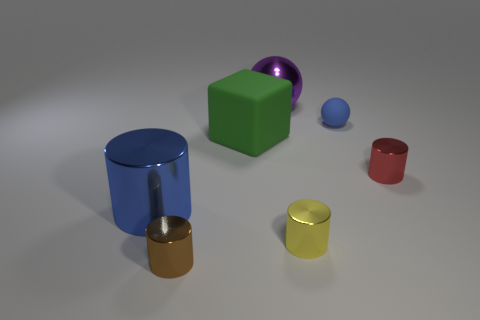Are there any other things that have the same shape as the green thing?
Give a very brief answer. No. There is a blue object that is behind the matte thing to the left of the purple object; what is its size?
Your response must be concise. Small. Does the green object have the same material as the blue object that is on the right side of the big cube?
Ensure brevity in your answer.  Yes. Is the number of rubber objects that are to the left of the large blue metallic cylinder less than the number of cylinders that are in front of the tiny red thing?
Provide a succinct answer. Yes. There is a small ball that is the same material as the green object; what is its color?
Provide a succinct answer. Blue. Are there any purple metallic balls that are to the right of the small thing to the left of the large metallic sphere?
Your answer should be compact. Yes. What color is the other metal object that is the same size as the purple shiny object?
Ensure brevity in your answer.  Blue. How many objects are metal cylinders or tiny brown metal things?
Keep it short and to the point. 4. How big is the sphere that is in front of the large purple sphere that is behind the small blue sphere that is behind the brown object?
Offer a very short reply. Small. How many things have the same color as the large metal cylinder?
Offer a terse response. 1. 